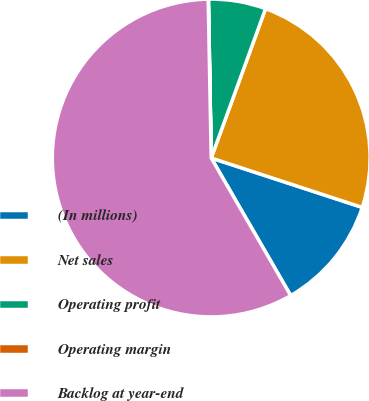Convert chart. <chart><loc_0><loc_0><loc_500><loc_500><pie_chart><fcel>(In millions)<fcel>Net sales<fcel>Operating profit<fcel>Operating margin<fcel>Backlog at year-end<nl><fcel>11.63%<fcel>24.48%<fcel>5.83%<fcel>0.03%<fcel>58.04%<nl></chart> 